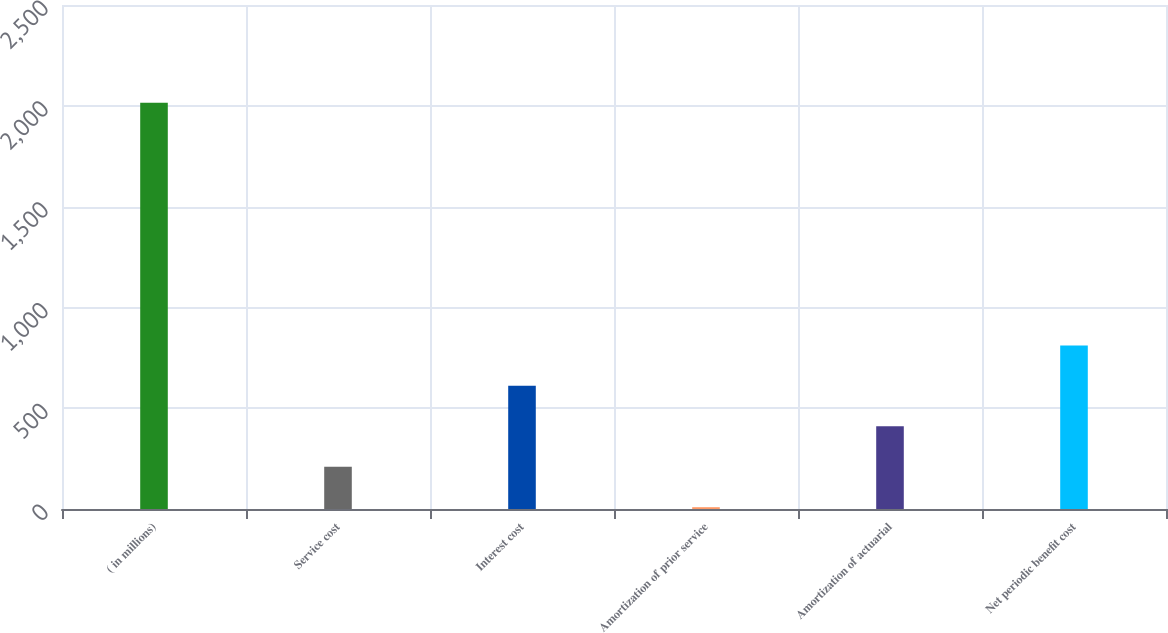Convert chart. <chart><loc_0><loc_0><loc_500><loc_500><bar_chart><fcel>( in millions)<fcel>Service cost<fcel>Interest cost<fcel>Amortization of prior service<fcel>Amortization of actuarial<fcel>Net periodic benefit cost<nl><fcel>2015<fcel>209.6<fcel>610.8<fcel>9<fcel>410.2<fcel>811.4<nl></chart> 